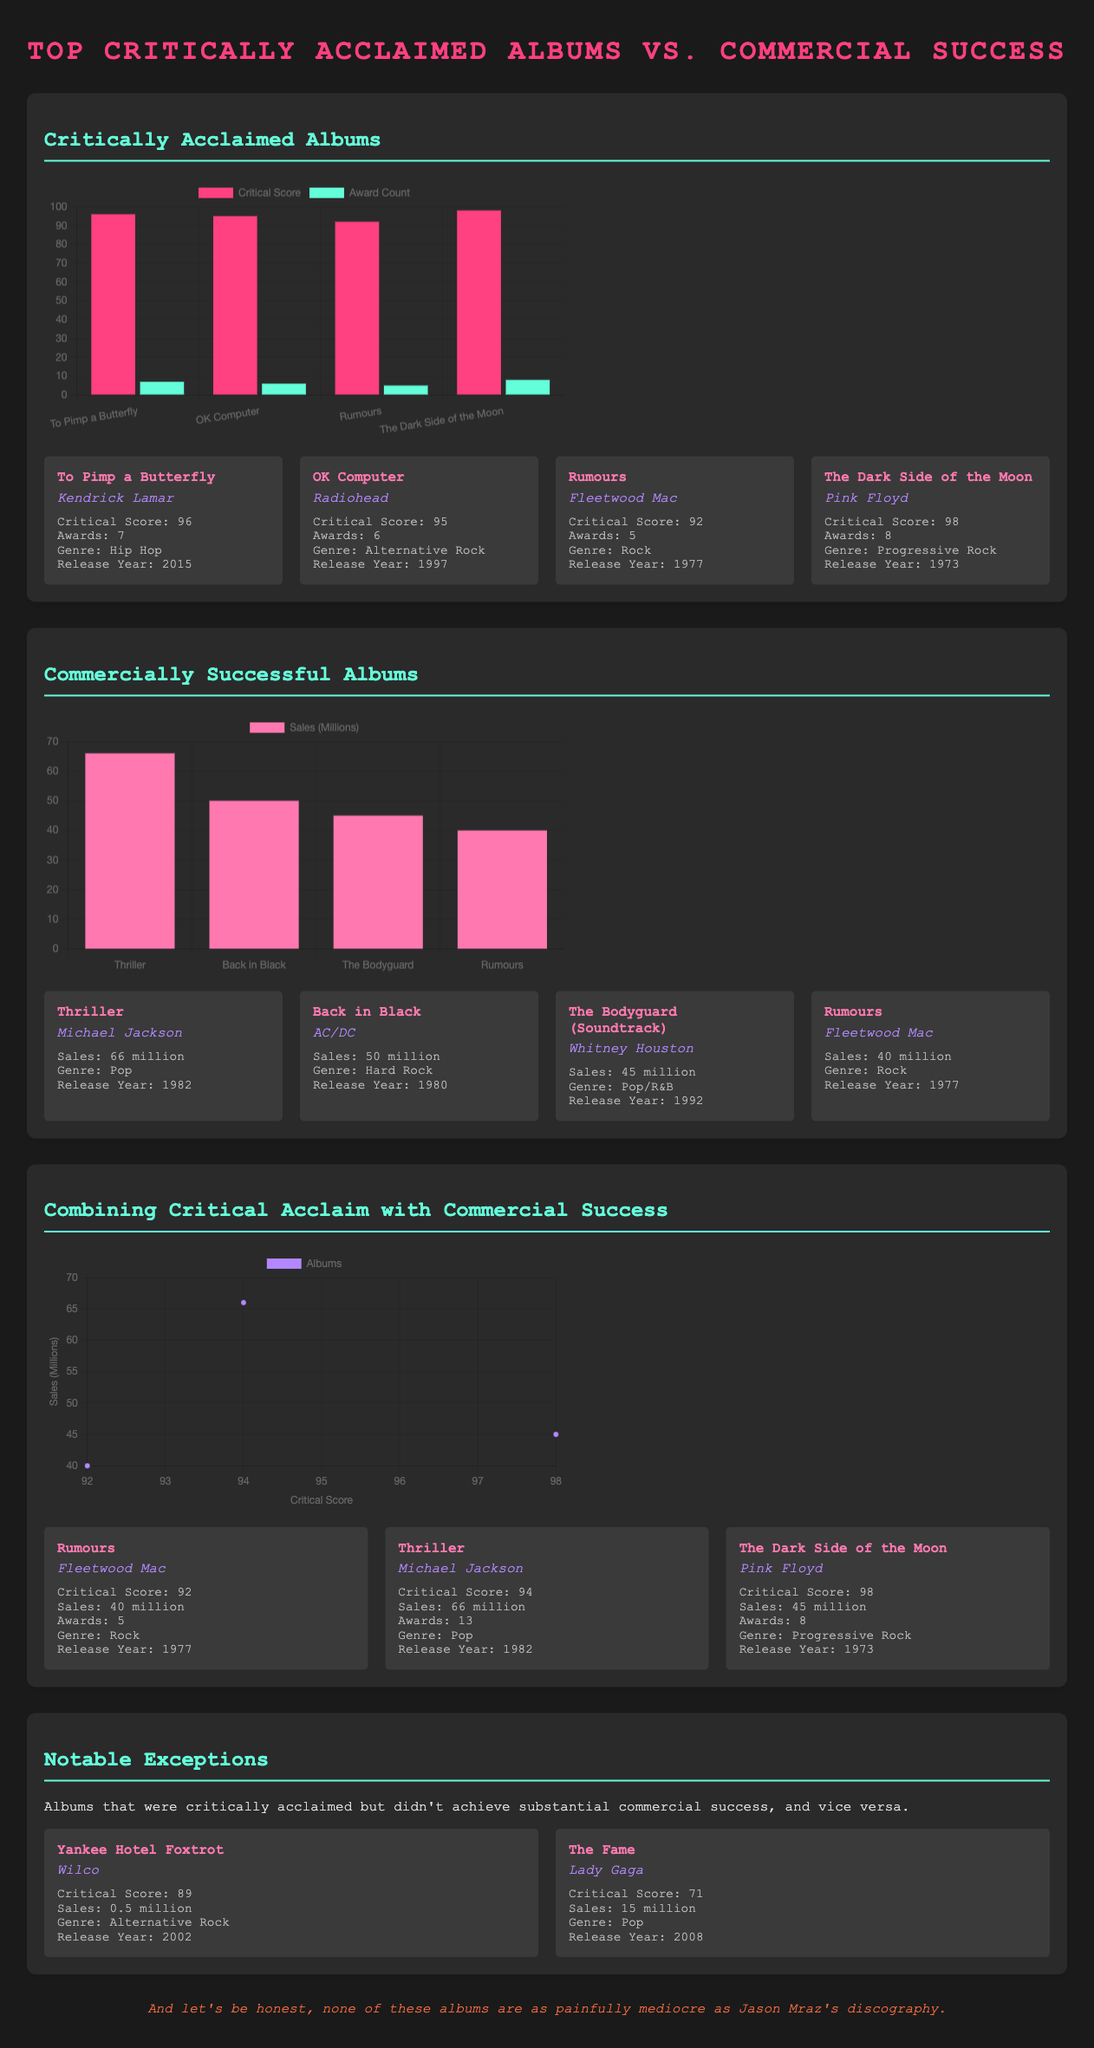what is the critical score of "The Dark Side of the Moon"? The critical score of "The Dark Side of the Moon" is mentioned in the album details section of the document.
Answer: 98 which album has the highest sales? The album with the highest sales is identified in the commercially successful albums section of the document.
Answer: Thriller how many awards did "To Pimp a Butterfly" win? The number of awards won by "To Pimp a Butterfly" is given in the album details section.
Answer: 7 which genre does "Yankee Hotel Foxtrot" belong to? The genre of "Yankee Hotel Foxtrot" can be found in its album details in the notable exceptions section.
Answer: Alternative Rock what is the sales figure for the album "Rumours"? The sales figure for "Rumours" is provided in both the critically acclaimed and commercially successful sections of the document.
Answer: 40 million which album is noted for having a critical score of 89 but low sales? This album is mentioned in the notable exceptions section of the document, specifically describing its critical acclaim versus its sales.
Answer: Yankee Hotel Foxtrot how many albums in the critically acclaimed section are by Fleetwood Mac? The number of albums by Fleetwood Mac in the critically acclaimed section is easily identifiable by looking at the list.
Answer: 1 what type of chart is used for combining critical acclaim with commercial success? The type of chart is specified in the combined chart section of the document, describing how the data is presented.
Answer: Scatter which artist has the album with the highest critical score on the chart? The artist associated with the album that has the highest critical score is found by examining the critical acclaim section.
Answer: Pink Floyd 